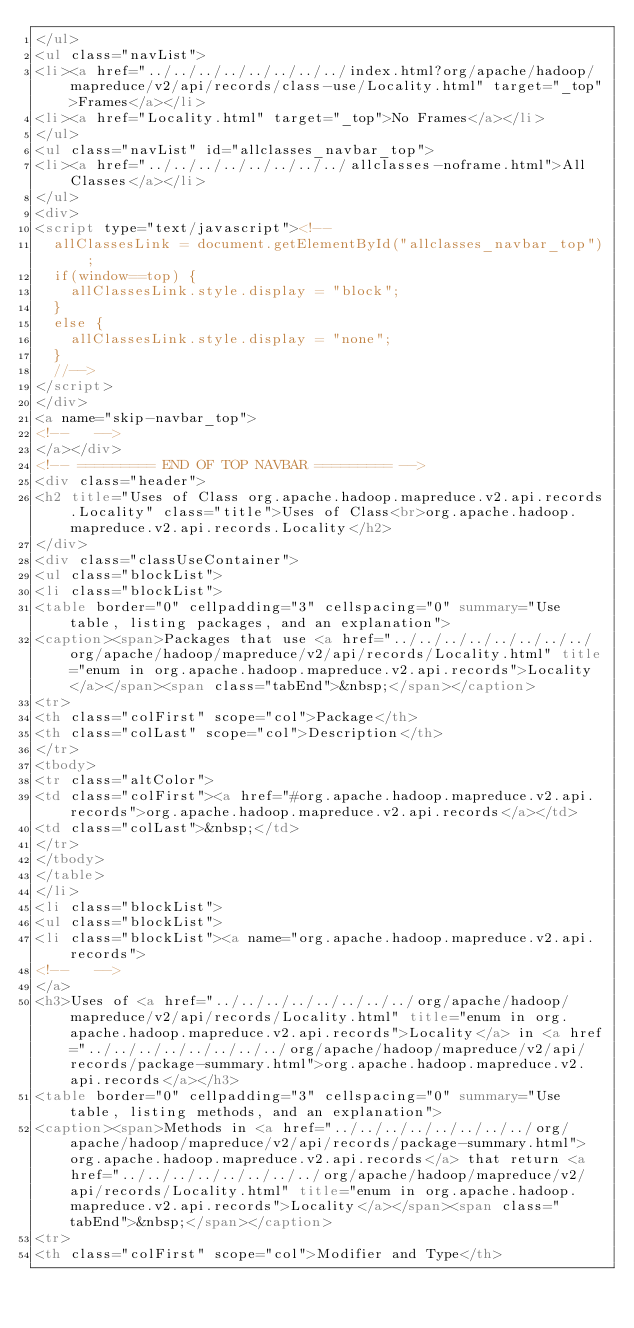Convert code to text. <code><loc_0><loc_0><loc_500><loc_500><_HTML_></ul>
<ul class="navList">
<li><a href="../../../../../../../../index.html?org/apache/hadoop/mapreduce/v2/api/records/class-use/Locality.html" target="_top">Frames</a></li>
<li><a href="Locality.html" target="_top">No Frames</a></li>
</ul>
<ul class="navList" id="allclasses_navbar_top">
<li><a href="../../../../../../../../allclasses-noframe.html">All Classes</a></li>
</ul>
<div>
<script type="text/javascript"><!--
  allClassesLink = document.getElementById("allclasses_navbar_top");
  if(window==top) {
    allClassesLink.style.display = "block";
  }
  else {
    allClassesLink.style.display = "none";
  }
  //-->
</script>
</div>
<a name="skip-navbar_top">
<!--   -->
</a></div>
<!-- ========= END OF TOP NAVBAR ========= -->
<div class="header">
<h2 title="Uses of Class org.apache.hadoop.mapreduce.v2.api.records.Locality" class="title">Uses of Class<br>org.apache.hadoop.mapreduce.v2.api.records.Locality</h2>
</div>
<div class="classUseContainer">
<ul class="blockList">
<li class="blockList">
<table border="0" cellpadding="3" cellspacing="0" summary="Use table, listing packages, and an explanation">
<caption><span>Packages that use <a href="../../../../../../../../org/apache/hadoop/mapreduce/v2/api/records/Locality.html" title="enum in org.apache.hadoop.mapreduce.v2.api.records">Locality</a></span><span class="tabEnd">&nbsp;</span></caption>
<tr>
<th class="colFirst" scope="col">Package</th>
<th class="colLast" scope="col">Description</th>
</tr>
<tbody>
<tr class="altColor">
<td class="colFirst"><a href="#org.apache.hadoop.mapreduce.v2.api.records">org.apache.hadoop.mapreduce.v2.api.records</a></td>
<td class="colLast">&nbsp;</td>
</tr>
</tbody>
</table>
</li>
<li class="blockList">
<ul class="blockList">
<li class="blockList"><a name="org.apache.hadoop.mapreduce.v2.api.records">
<!--   -->
</a>
<h3>Uses of <a href="../../../../../../../../org/apache/hadoop/mapreduce/v2/api/records/Locality.html" title="enum in org.apache.hadoop.mapreduce.v2.api.records">Locality</a> in <a href="../../../../../../../../org/apache/hadoop/mapreduce/v2/api/records/package-summary.html">org.apache.hadoop.mapreduce.v2.api.records</a></h3>
<table border="0" cellpadding="3" cellspacing="0" summary="Use table, listing methods, and an explanation">
<caption><span>Methods in <a href="../../../../../../../../org/apache/hadoop/mapreduce/v2/api/records/package-summary.html">org.apache.hadoop.mapreduce.v2.api.records</a> that return <a href="../../../../../../../../org/apache/hadoop/mapreduce/v2/api/records/Locality.html" title="enum in org.apache.hadoop.mapreduce.v2.api.records">Locality</a></span><span class="tabEnd">&nbsp;</span></caption>
<tr>
<th class="colFirst" scope="col">Modifier and Type</th></code> 